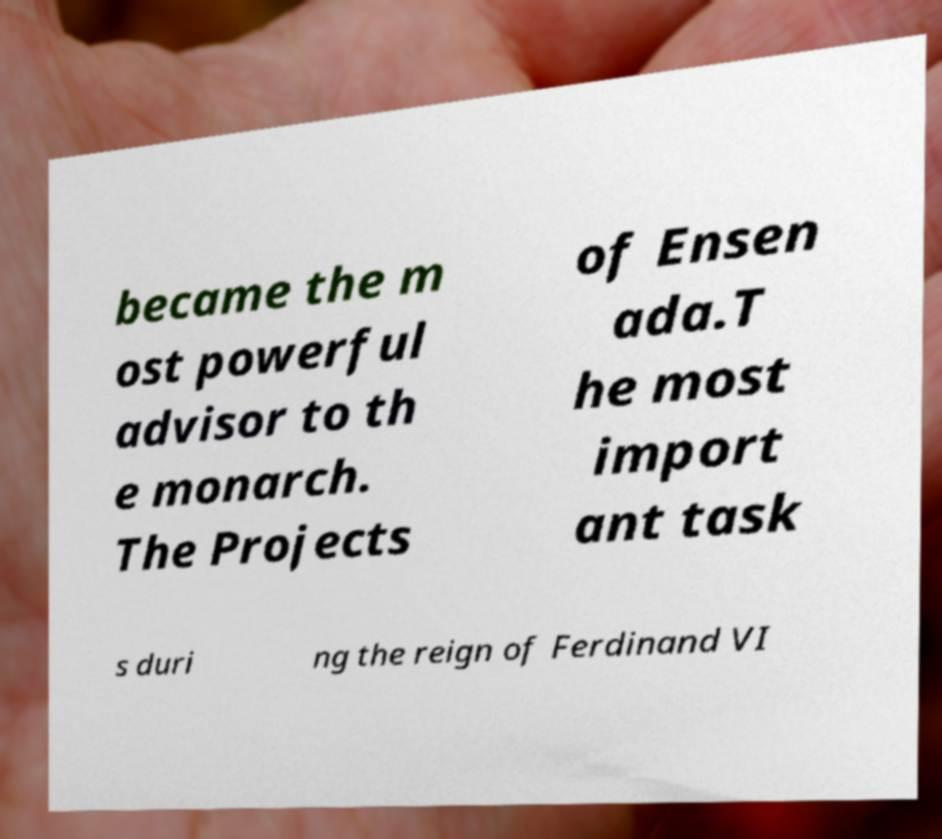There's text embedded in this image that I need extracted. Can you transcribe it verbatim? became the m ost powerful advisor to th e monarch. The Projects of Ensen ada.T he most import ant task s duri ng the reign of Ferdinand VI 